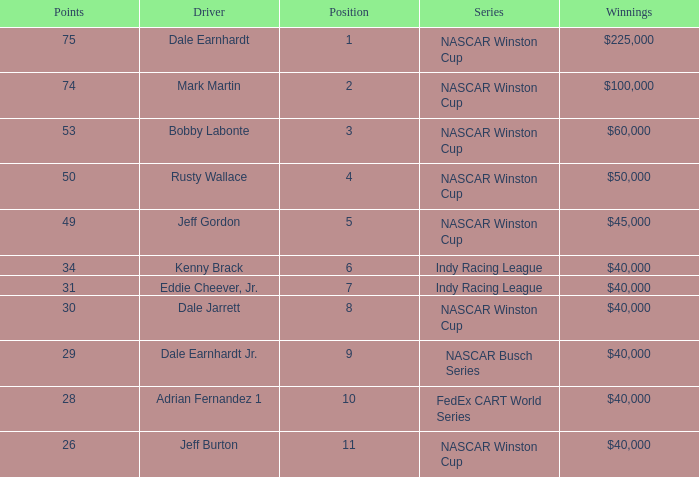In what series did Bobby Labonte drive? NASCAR Winston Cup. 